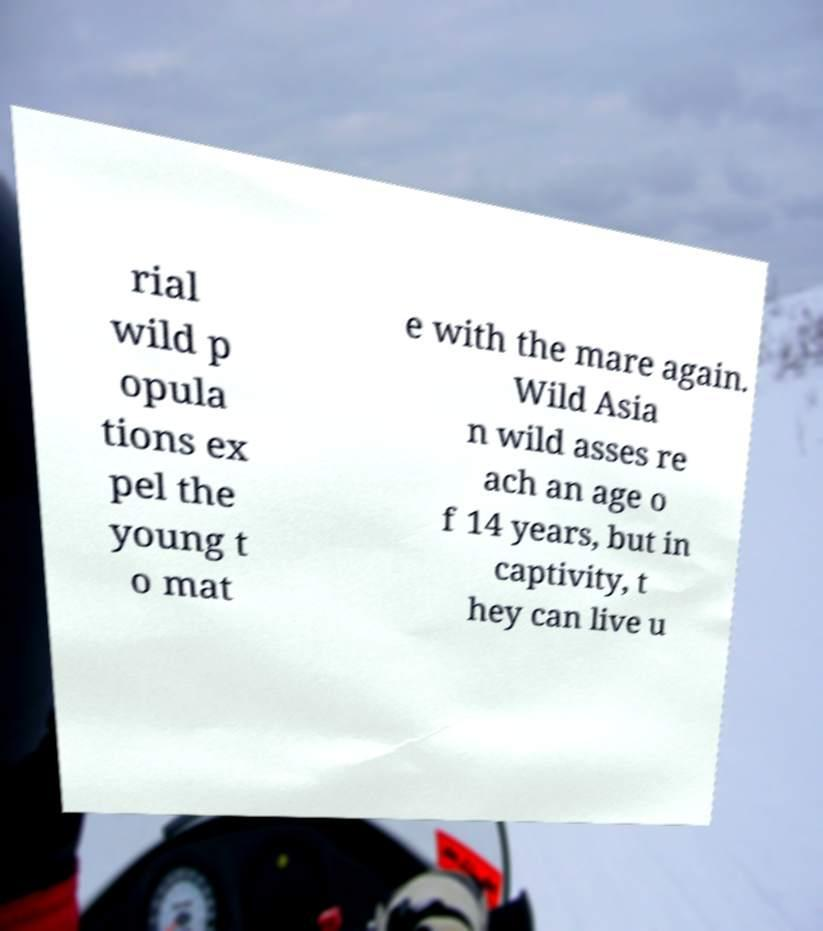Could you assist in decoding the text presented in this image and type it out clearly? rial wild p opula tions ex pel the young t o mat e with the mare again. Wild Asia n wild asses re ach an age o f 14 years, but in captivity, t hey can live u 